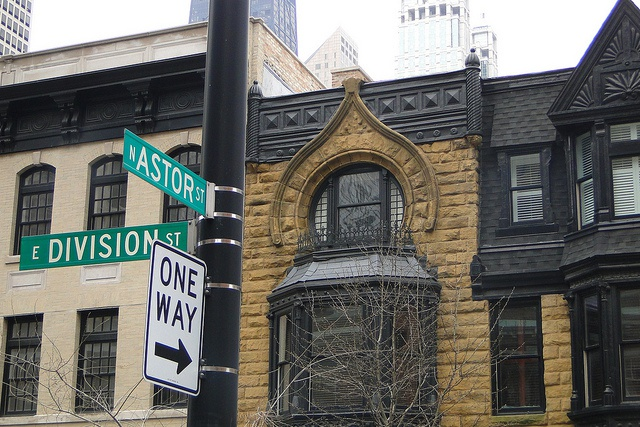Describe the objects in this image and their specific colors. I can see various objects in this image with different colors. 